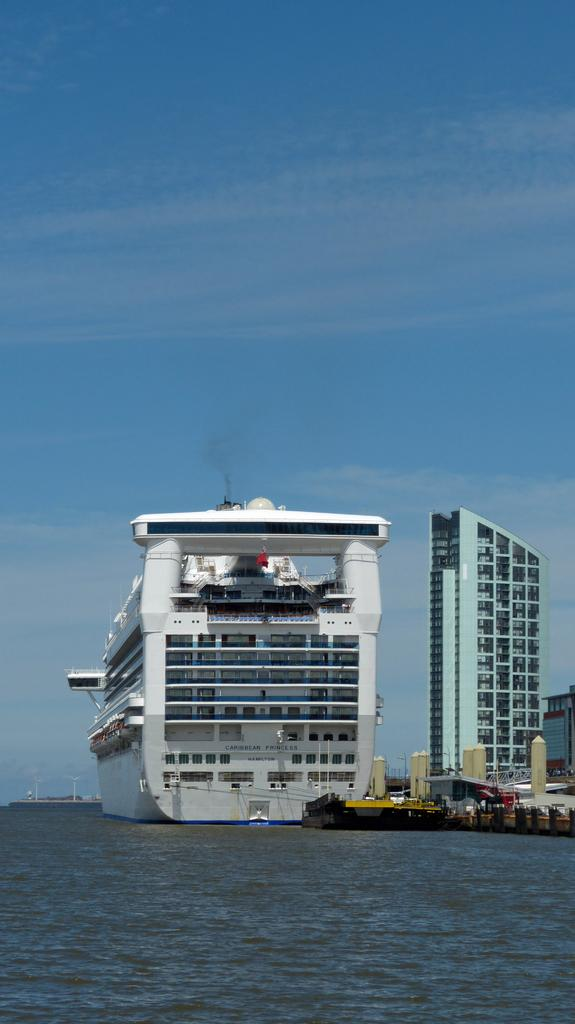What is the main subject of the image? The main subject of the image is a ship. Where is the ship located in the image? The ship is on the water. What can be seen in the background of the image? There are buildings in the background of the image. What is visible at the top of the image? The sky is visible at the top of the image. How does the ship sort the snow in the image? There is no snow present in the image, and ships do not sort snow. 